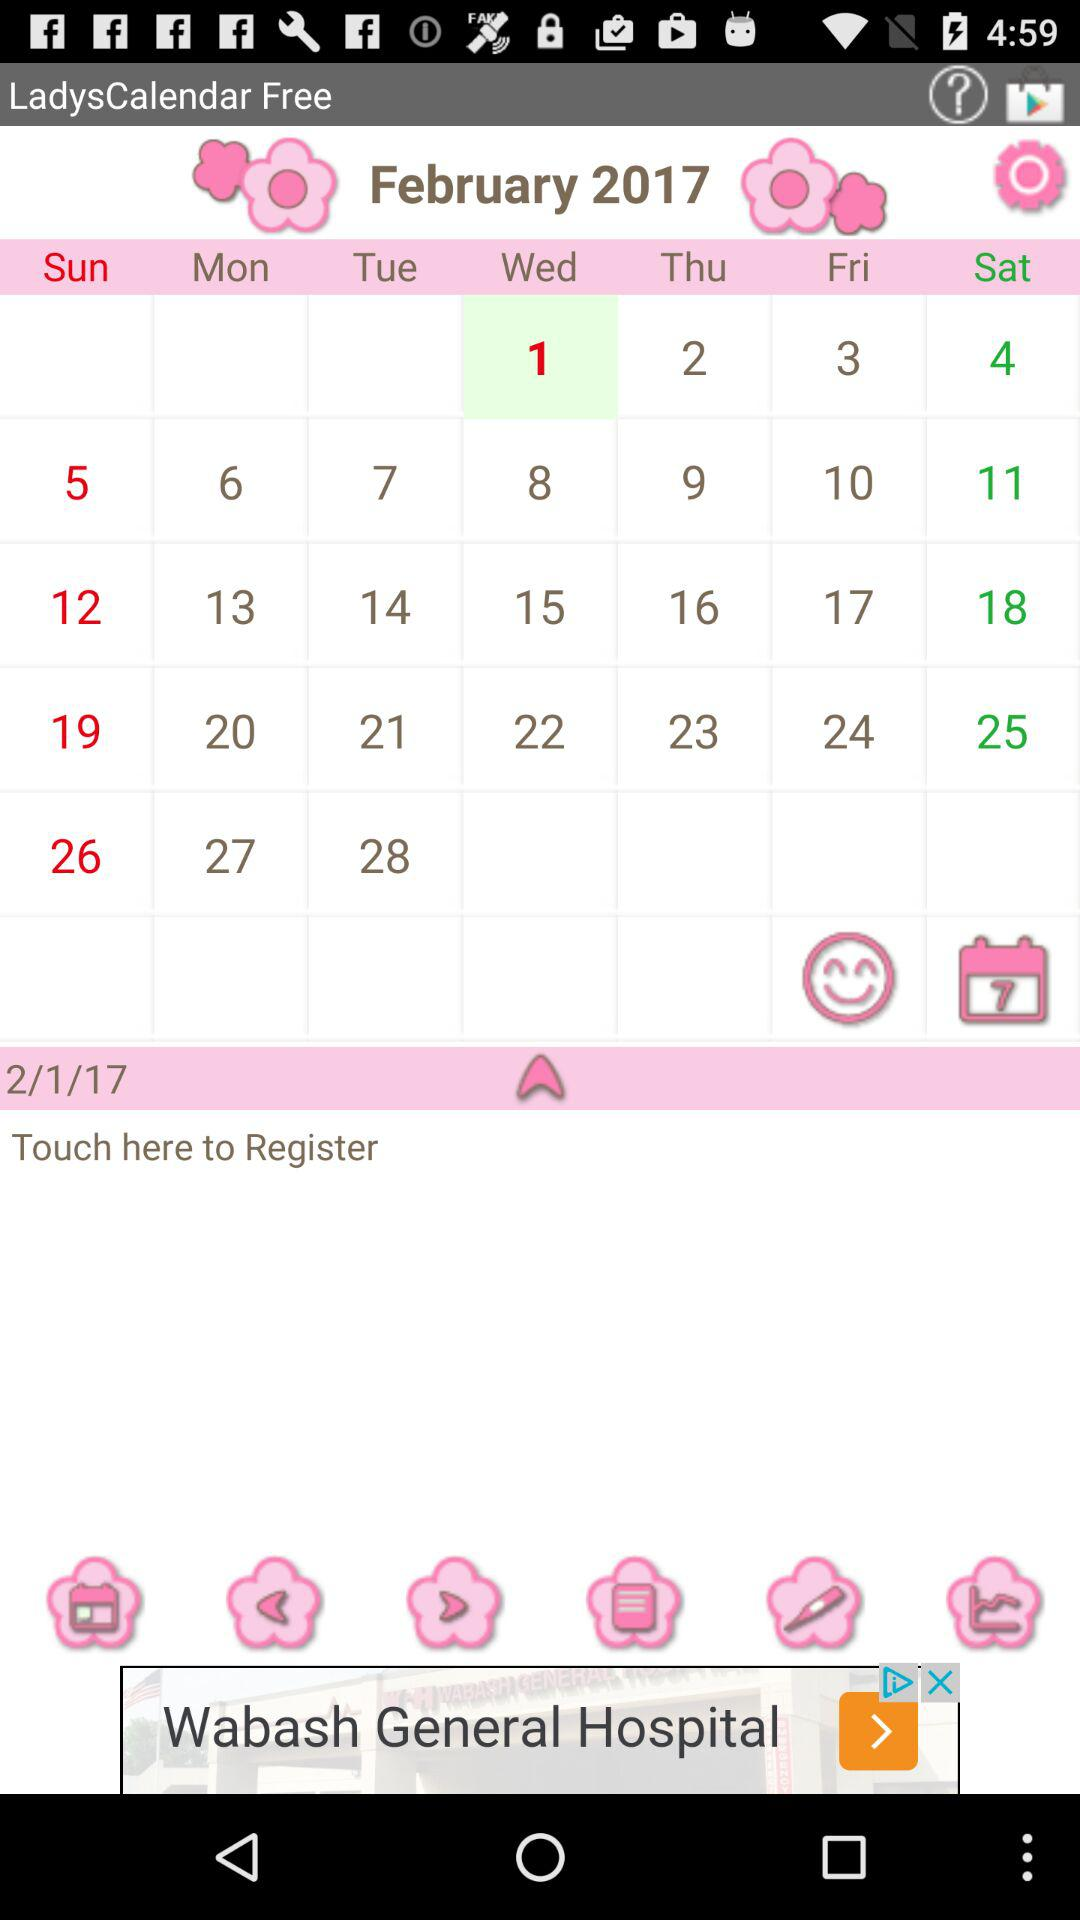How many days are shown in the calendar?
Answer the question using a single word or phrase. 28 